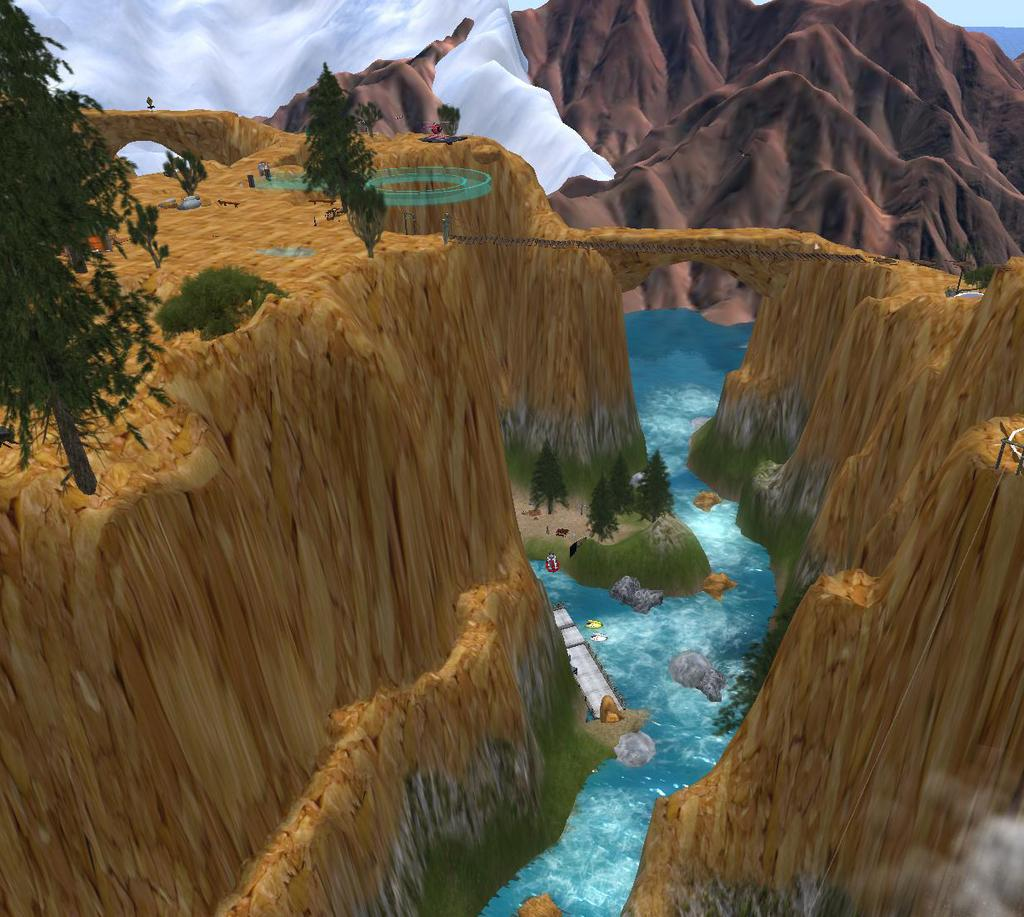What type of image is this, based on the provided facts? The image appears to be animated. What natural elements can be seen in the image? There are trees, a river with water flowing, and rocks visible in the image. What man-made structure is present in the image? There is a wooden bridge in the image. Can you describe the landscape in the image? The image may depict a snow mountain. What type of music is being played by the judge in the image? There is no judge or music present in the image. Is the beggar asking for alms near the river in the image? There is no beggar present in the image. 